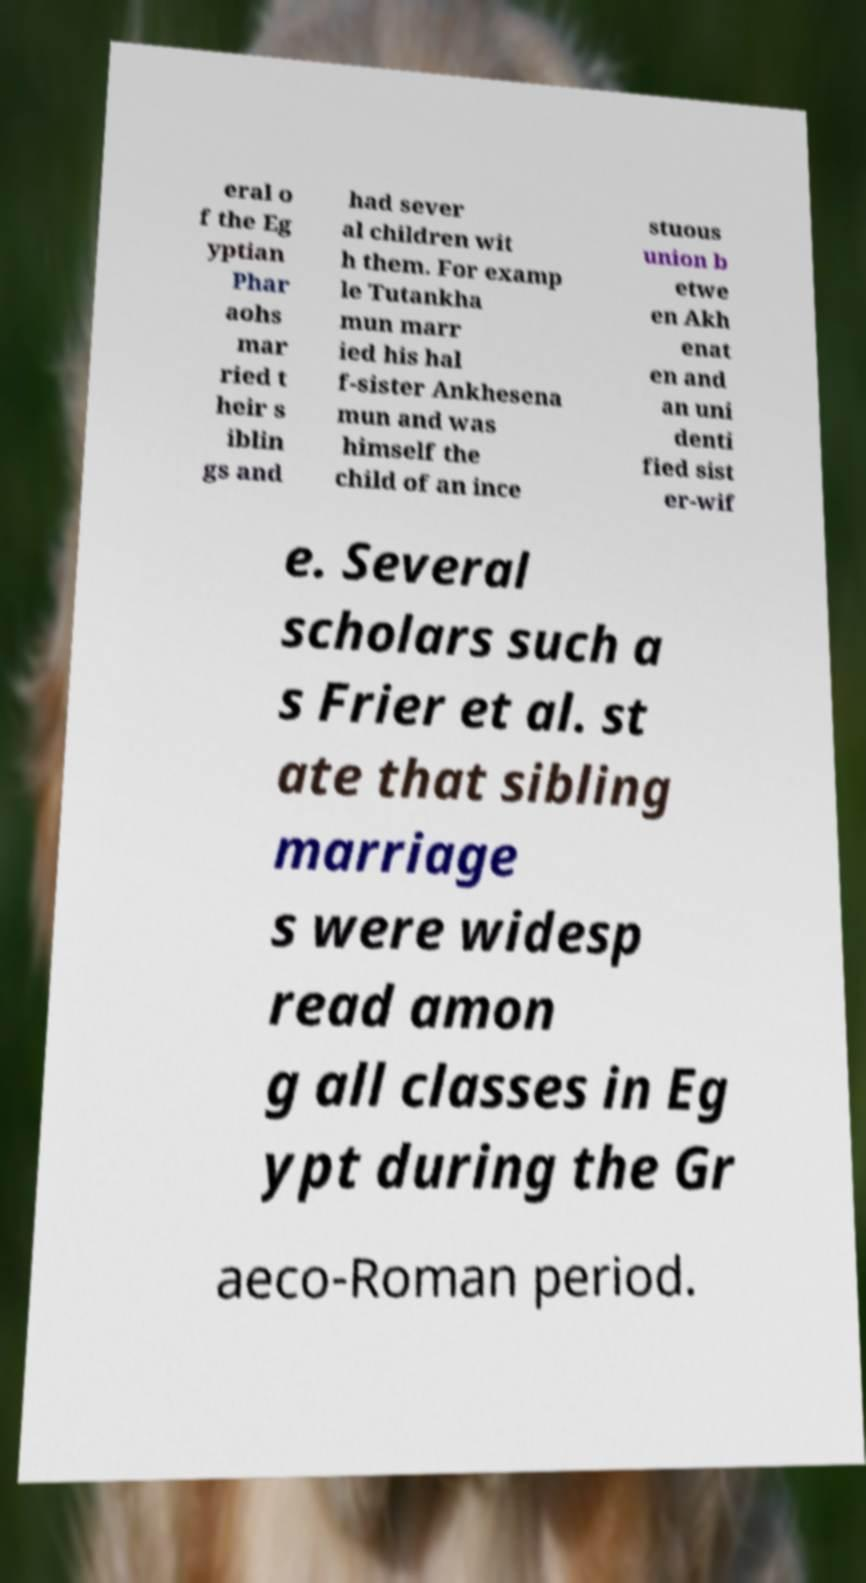Can you read and provide the text displayed in the image?This photo seems to have some interesting text. Can you extract and type it out for me? eral o f the Eg yptian Phar aohs mar ried t heir s iblin gs and had sever al children wit h them. For examp le Tutankha mun marr ied his hal f-sister Ankhesena mun and was himself the child of an ince stuous union b etwe en Akh enat en and an uni denti fied sist er-wif e. Several scholars such a s Frier et al. st ate that sibling marriage s were widesp read amon g all classes in Eg ypt during the Gr aeco-Roman period. 